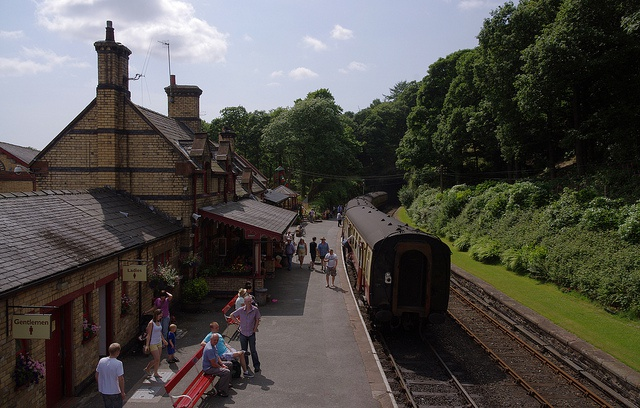Describe the objects in this image and their specific colors. I can see train in lavender, black, gray, and maroon tones, bench in lavender, gray, maroon, brown, and black tones, people in lavender, gray, black, and maroon tones, people in lavender, black, purple, gray, and maroon tones, and potted plant in lavender, black, and purple tones in this image. 